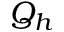Convert formula to latex. <formula><loc_0><loc_0><loc_500><loc_500>Q _ { h }</formula> 